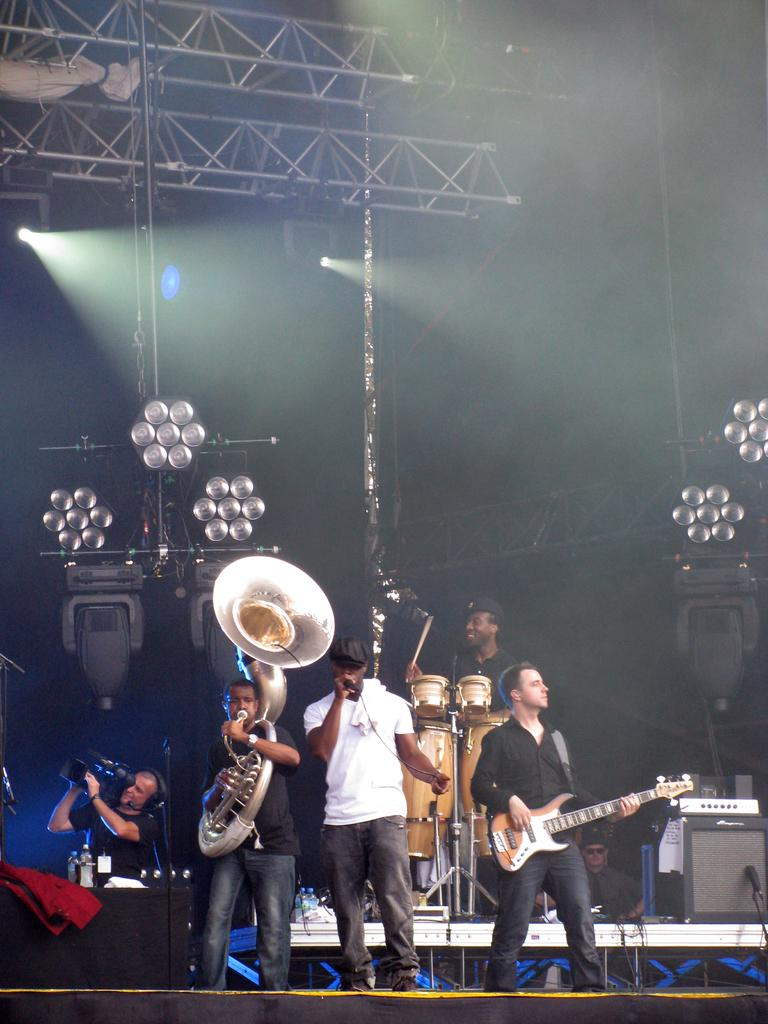What are the people in the image doing? The people in the image are performing. What are the people performing doing specifically? The people are playing musical instruments. Can you describe the person recording the performance? There is a man recording the performance with a video camera. How many girls are playing with the cream in the image? There are no girls or cream present in the image. What type of music is being played by the performers in the image? The provided facts do not specify the type of music being played by the performers. 